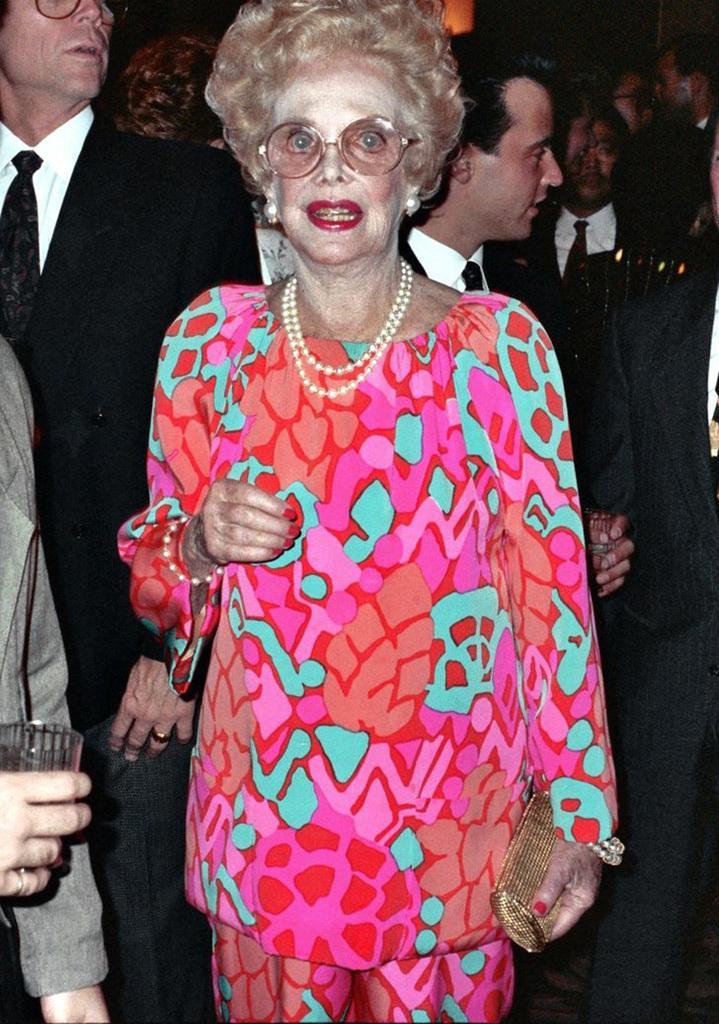Please provide a concise description of this image. In this image we can see some people standing. In that a woman is holding a purse and a man is holding a glass. 